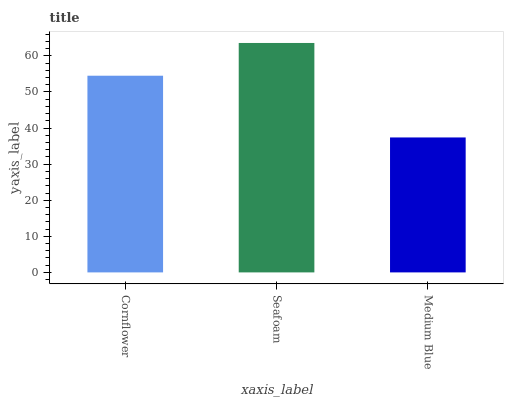Is Medium Blue the minimum?
Answer yes or no. Yes. Is Seafoam the maximum?
Answer yes or no. Yes. Is Seafoam the minimum?
Answer yes or no. No. Is Medium Blue the maximum?
Answer yes or no. No. Is Seafoam greater than Medium Blue?
Answer yes or no. Yes. Is Medium Blue less than Seafoam?
Answer yes or no. Yes. Is Medium Blue greater than Seafoam?
Answer yes or no. No. Is Seafoam less than Medium Blue?
Answer yes or no. No. Is Cornflower the high median?
Answer yes or no. Yes. Is Cornflower the low median?
Answer yes or no. Yes. Is Seafoam the high median?
Answer yes or no. No. Is Seafoam the low median?
Answer yes or no. No. 